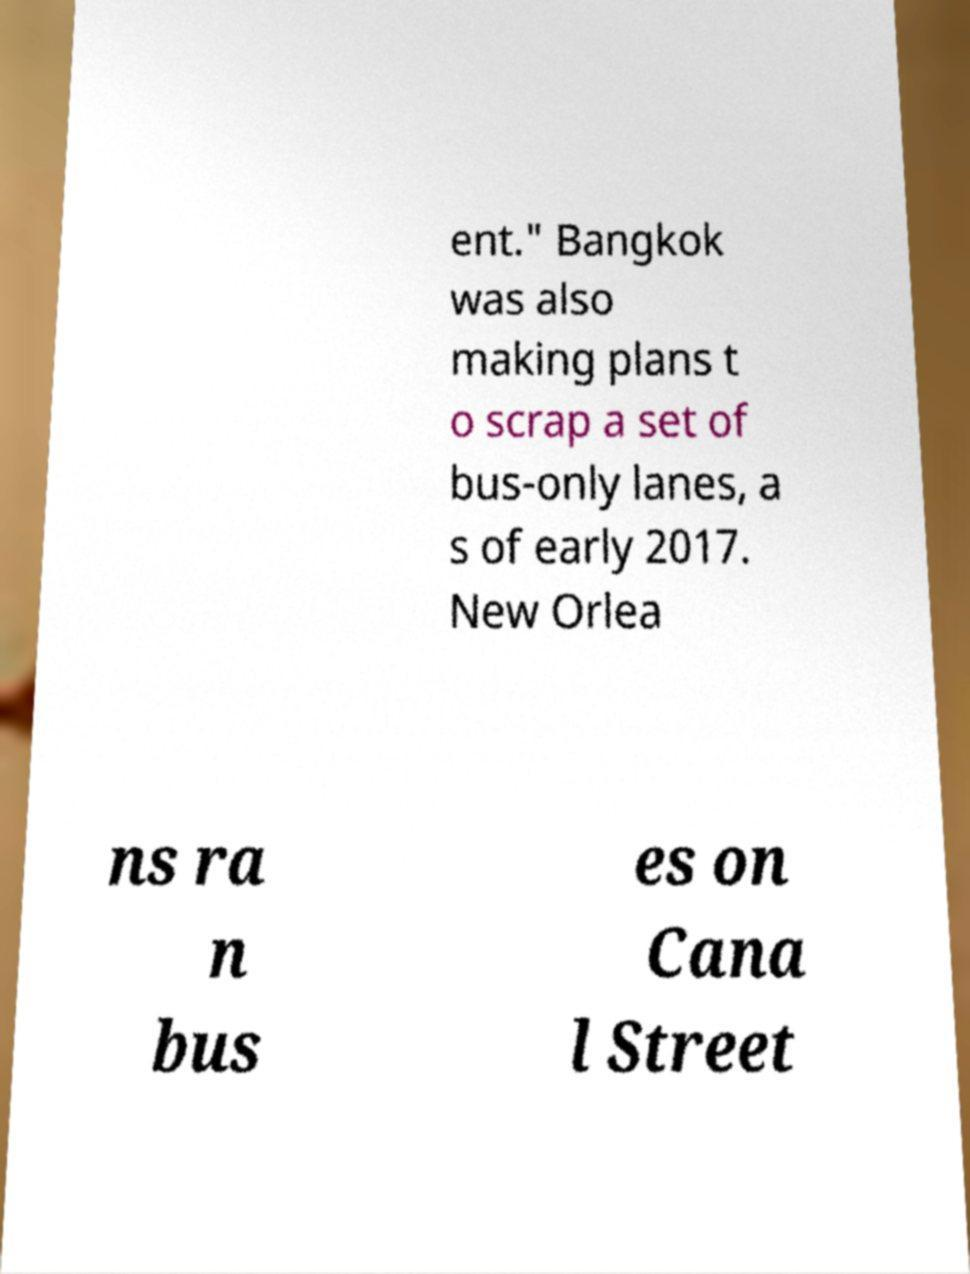Can you accurately transcribe the text from the provided image for me? ent." Bangkok was also making plans t o scrap a set of bus-only lanes, a s of early 2017. New Orlea ns ra n bus es on Cana l Street 